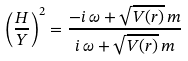Convert formula to latex. <formula><loc_0><loc_0><loc_500><loc_500>\left ( \frac { H } { Y } \right ) ^ { 2 } = \frac { - i \, \omega + \sqrt { V ( r ) } \, m } { i \, \omega + \sqrt { V ( r ) } \, m }</formula> 